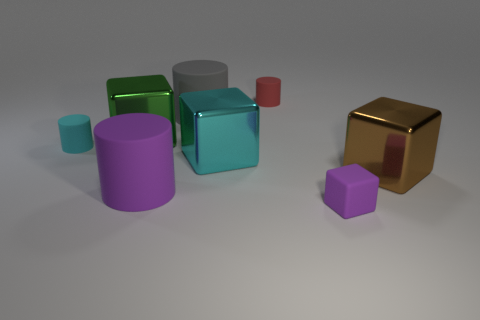There is a rubber object that is the same color as the matte cube; what is its shape?
Your answer should be very brief. Cylinder. What number of green metal blocks are the same size as the rubber cube?
Ensure brevity in your answer.  0. Do the red matte thing behind the large purple cylinder and the purple thing to the left of the tiny purple matte object have the same size?
Ensure brevity in your answer.  No. There is a large object to the right of the large cyan block; what is its shape?
Give a very brief answer. Cube. What is the big object that is left of the large rubber thing in front of the large brown block made of?
Keep it short and to the point. Metal. Are there any large rubber things of the same color as the rubber block?
Provide a short and direct response. Yes. Is the size of the gray thing the same as the purple object right of the gray rubber object?
Provide a succinct answer. No. There is a tiny purple object that is right of the small object behind the big gray matte cylinder; how many shiny cubes are on the right side of it?
Ensure brevity in your answer.  1. How many big matte things are to the right of the tiny cube?
Provide a short and direct response. 0. There is a large cylinder behind the metallic thing that is behind the large cyan cube; what color is it?
Make the answer very short. Gray. 